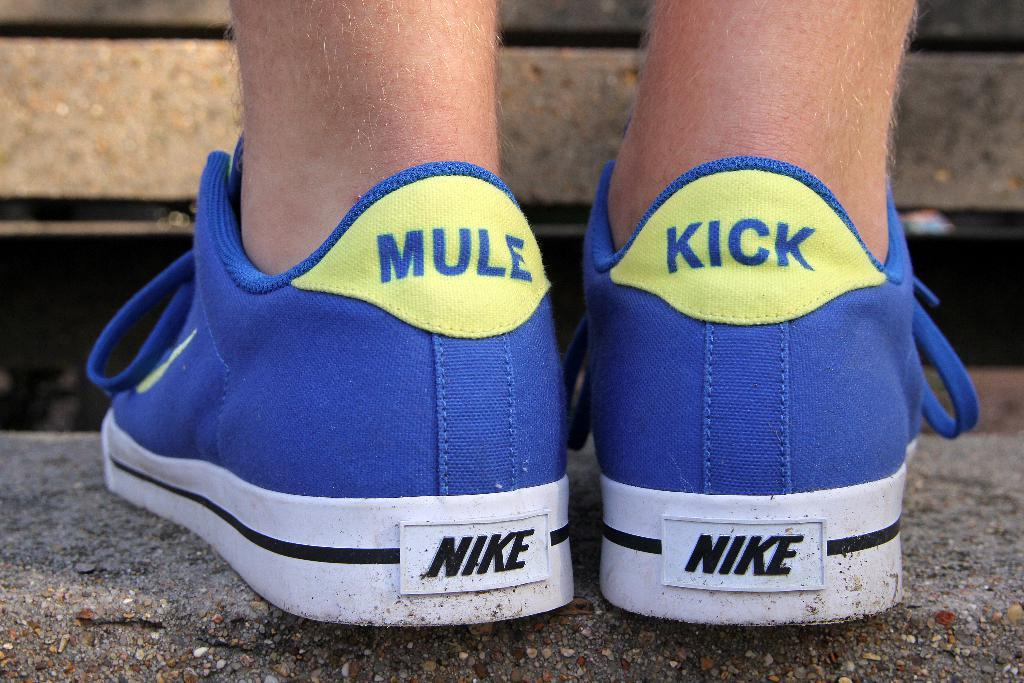<image>
Summarize the visual content of the image. Someone is wearing a pair of Nike sneakers that say mule kick on the backs. 